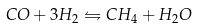Convert formula to latex. <formula><loc_0><loc_0><loc_500><loc_500>C O + 3 H _ { 2 } \leftrightharpoons C H _ { 4 } + H _ { 2 } O</formula> 